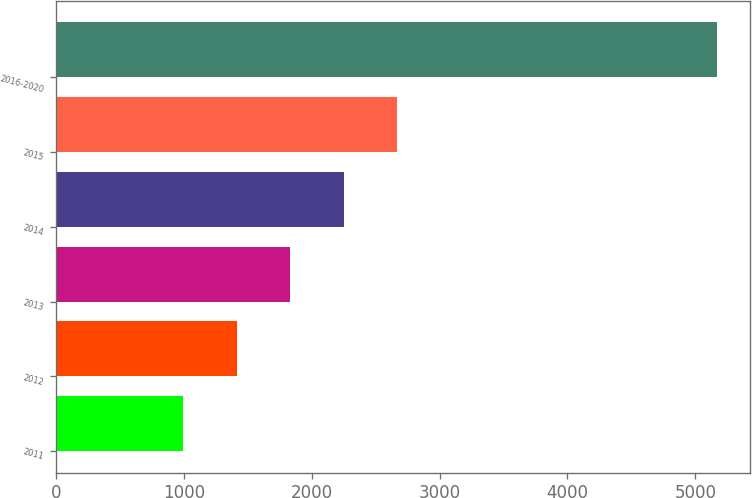<chart> <loc_0><loc_0><loc_500><loc_500><bar_chart><fcel>2011<fcel>2012<fcel>2013<fcel>2014<fcel>2015<fcel>2016-2020<nl><fcel>996<fcel>1413.6<fcel>1831.2<fcel>2248.8<fcel>2666.4<fcel>5172<nl></chart> 